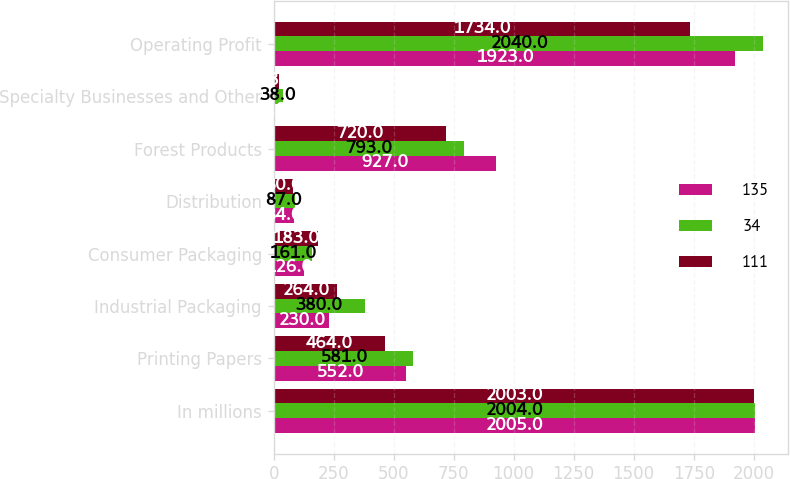Convert chart to OTSL. <chart><loc_0><loc_0><loc_500><loc_500><stacked_bar_chart><ecel><fcel>In millions<fcel>Printing Papers<fcel>Industrial Packaging<fcel>Consumer Packaging<fcel>Distribution<fcel>Forest Products<fcel>Specialty Businesses and Other<fcel>Operating Profit<nl><fcel>135<fcel>2005<fcel>552<fcel>230<fcel>126<fcel>84<fcel>927<fcel>4<fcel>1923<nl><fcel>34<fcel>2004<fcel>581<fcel>380<fcel>161<fcel>87<fcel>793<fcel>38<fcel>2040<nl><fcel>111<fcel>2003<fcel>464<fcel>264<fcel>183<fcel>80<fcel>720<fcel>23<fcel>1734<nl></chart> 